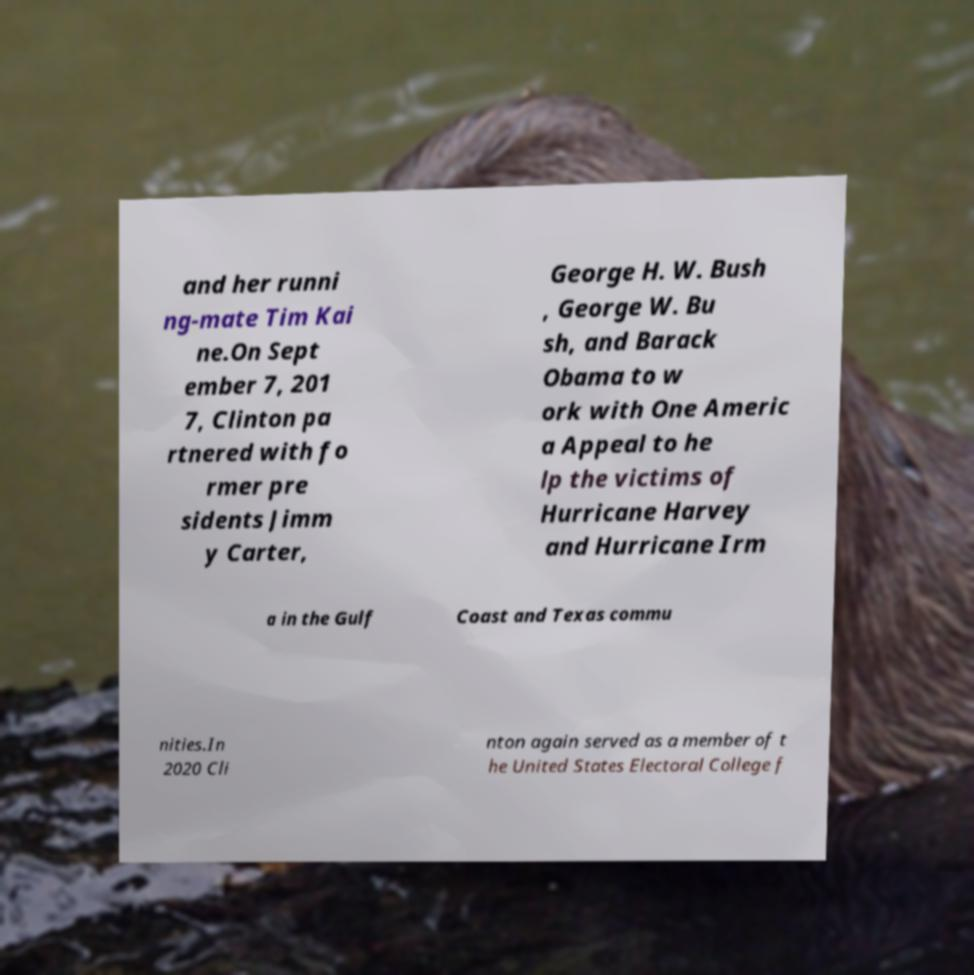What messages or text are displayed in this image? I need them in a readable, typed format. and her runni ng-mate Tim Kai ne.On Sept ember 7, 201 7, Clinton pa rtnered with fo rmer pre sidents Jimm y Carter, George H. W. Bush , George W. Bu sh, and Barack Obama to w ork with One Americ a Appeal to he lp the victims of Hurricane Harvey and Hurricane Irm a in the Gulf Coast and Texas commu nities.In 2020 Cli nton again served as a member of t he United States Electoral College f 